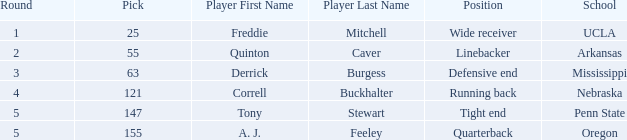What position did the player who was picked in round 3 play? Defensive end. 